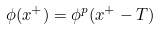Convert formula to latex. <formula><loc_0><loc_0><loc_500><loc_500>\phi ( x ^ { + } ) = \phi ^ { p } ( x ^ { + } - T )</formula> 